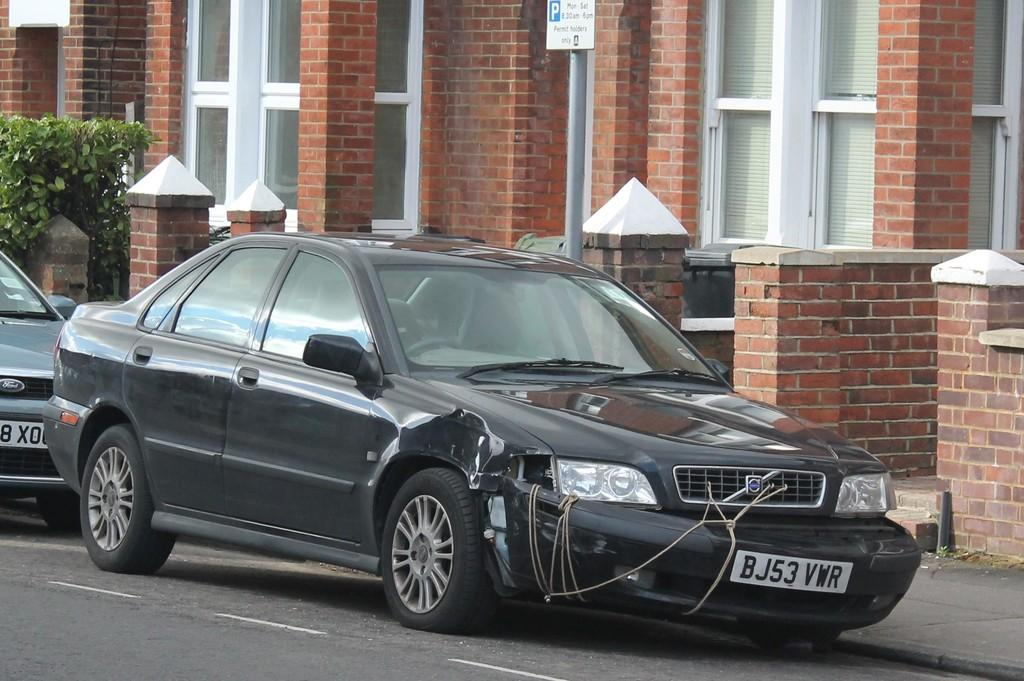<image>
Summarize the visual content of the image. a black car with the letter B on the license plate 